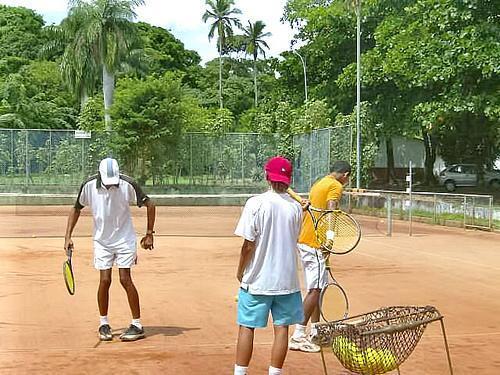How many people are in the photo?
Give a very brief answer. 3. How many elephants in the scene?
Give a very brief answer. 0. 